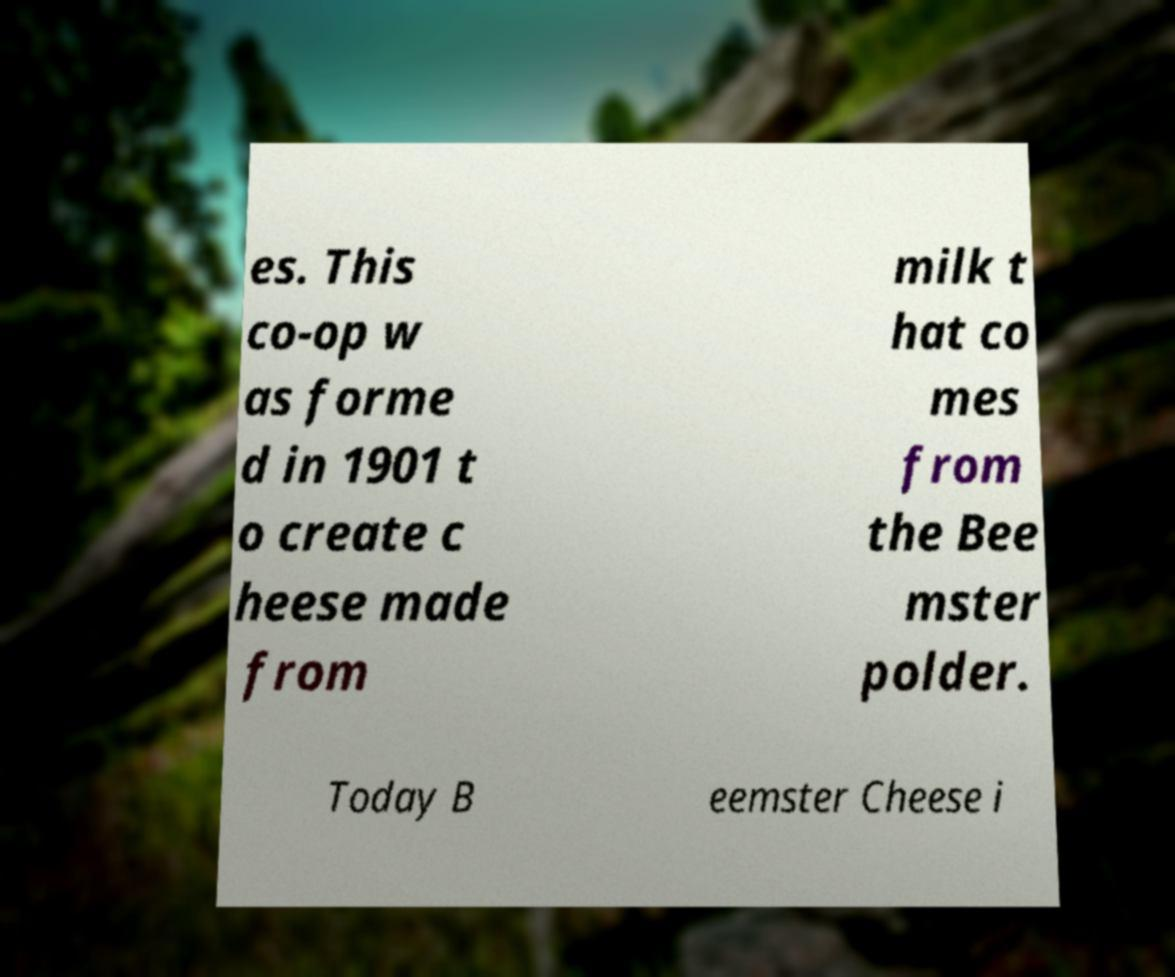Can you accurately transcribe the text from the provided image for me? es. This co-op w as forme d in 1901 t o create c heese made from milk t hat co mes from the Bee mster polder. Today B eemster Cheese i 